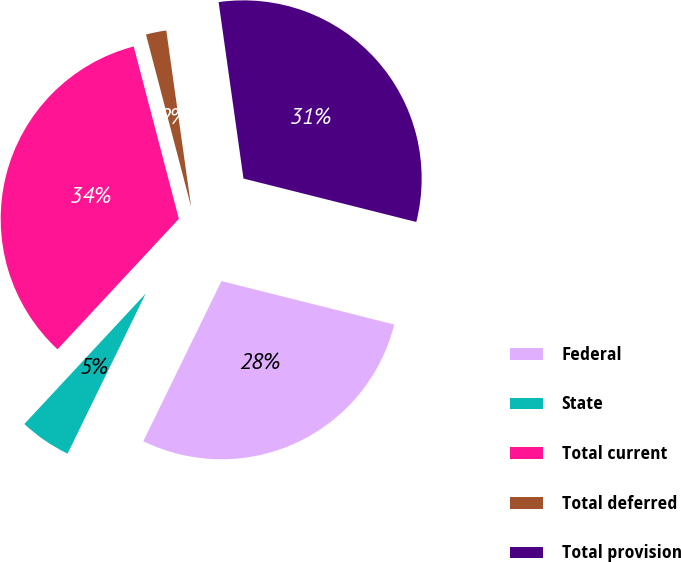Convert chart. <chart><loc_0><loc_0><loc_500><loc_500><pie_chart><fcel>Federal<fcel>State<fcel>Total current<fcel>Total deferred<fcel>Total provision<nl><fcel>28.31%<fcel>4.7%<fcel>34.0%<fcel>1.85%<fcel>31.15%<nl></chart> 